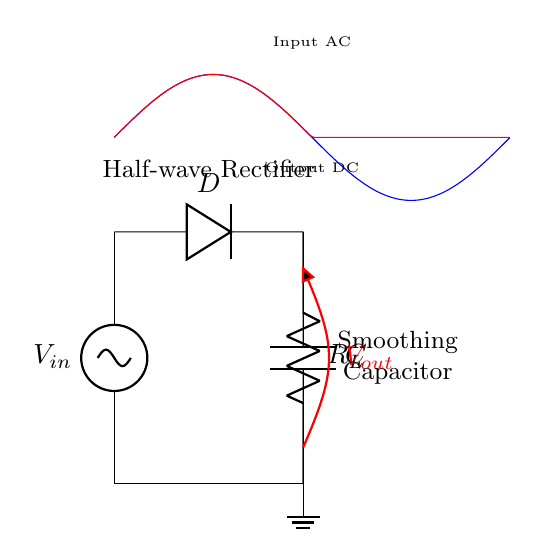What type of rectifier is shown in the circuit? The components and the function overview indicate that the circuit is specifically designed to allow current to pass through in only one direction, and it's labeled as a "Half-wave Rectifier".
Answer: Half-wave Rectifier What component is used to smooth the output voltage? The circuit diagram includes a capacitor labeled "C" connected in parallel with the load resistor, which serves to smooth the fluctuations in the output voltage.
Answer: Capacitor What is the main function of the diode in this circuit? The diode labeled "D" is crucial as it only allows current to flow in one direction, thereby converting the AC input voltage into DC output.
Answer: To allow current in one direction What will happen to the output voltage when the capacitor is added? The addition of the capacitor helps to reduce the ripple effect in the output voltage, leading to a more stable and smoother DC voltage signal across the load resistor.
Answer: Reduced ripple How does the load resistor affect the circuit's output? The load resistor, labeled "R_L", will impact the amount of current supplied to the load and the voltage drop across it, affecting the overall performance of the rectifier circuit.
Answer: Affects output current and voltage drop What type of waveform is expected at the output of this circuit? Based on the characteristics of a half-wave rectifier combined with a smoothing capacitor, the output will be a pulsating DC waveform with reduced ripple compared to the input AC waveform.
Answer: Pulsating DC How does the input AC voltage compare to the output DC voltage? The output DC voltage is typically lower than the peak value of the input AC voltage due to the diode forward voltage drop, along with the smoothing action of the capacitor.
Answer: Lower than peak AC voltage 